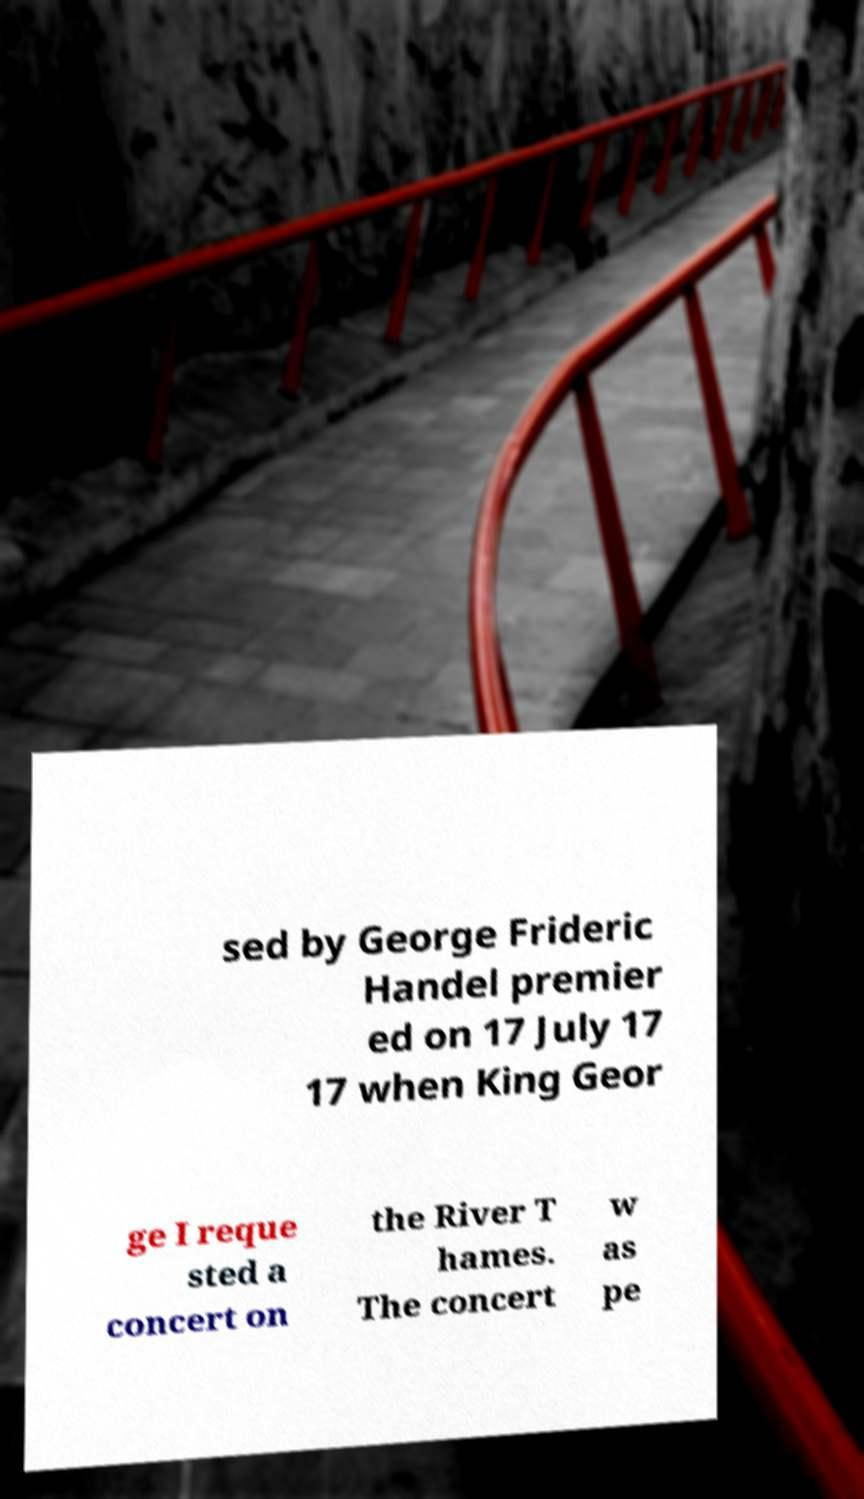Please identify and transcribe the text found in this image. sed by George Frideric Handel premier ed on 17 July 17 17 when King Geor ge I reque sted a concert on the River T hames. The concert w as pe 